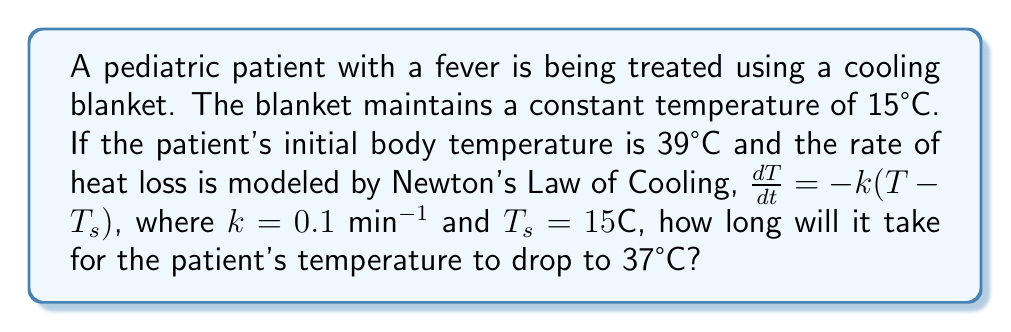Show me your answer to this math problem. To solve this problem, we'll use the solution to Newton's Law of Cooling:

$$T(t) = T_s + (T_0 - T_s)e^{-kt}$$

Where:
$T(t)$ is the temperature at time $t$
$T_s$ is the surrounding temperature (15°C)
$T_0$ is the initial temperature (39°C)
$k$ is the cooling constant (0.1 min^(-1))

1. Substitute the known values into the equation:
   $$37 = 15 + (39 - 15)e^{-0.1t}$$

2. Simplify:
   $$37 = 15 + 24e^{-0.1t}$$

3. Subtract 15 from both sides:
   $$22 = 24e^{-0.1t}$$

4. Divide both sides by 24:
   $$\frac{22}{24} = e^{-0.1t}$$

5. Take the natural logarithm of both sides:
   $$\ln(\frac{22}{24}) = -0.1t$$

6. Solve for $t$:
   $$t = -\frac{\ln(\frac{22}{24})}{0.1} \approx 8.76 \text{ minutes}$$
Answer: 8.76 minutes 